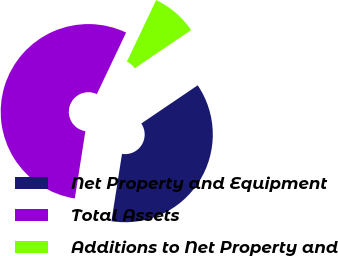Convert chart to OTSL. <chart><loc_0><loc_0><loc_500><loc_500><pie_chart><fcel>Net Property and Equipment<fcel>Total Assets<fcel>Additions to Net Property and<nl><fcel>36.96%<fcel>54.58%<fcel>8.46%<nl></chart> 